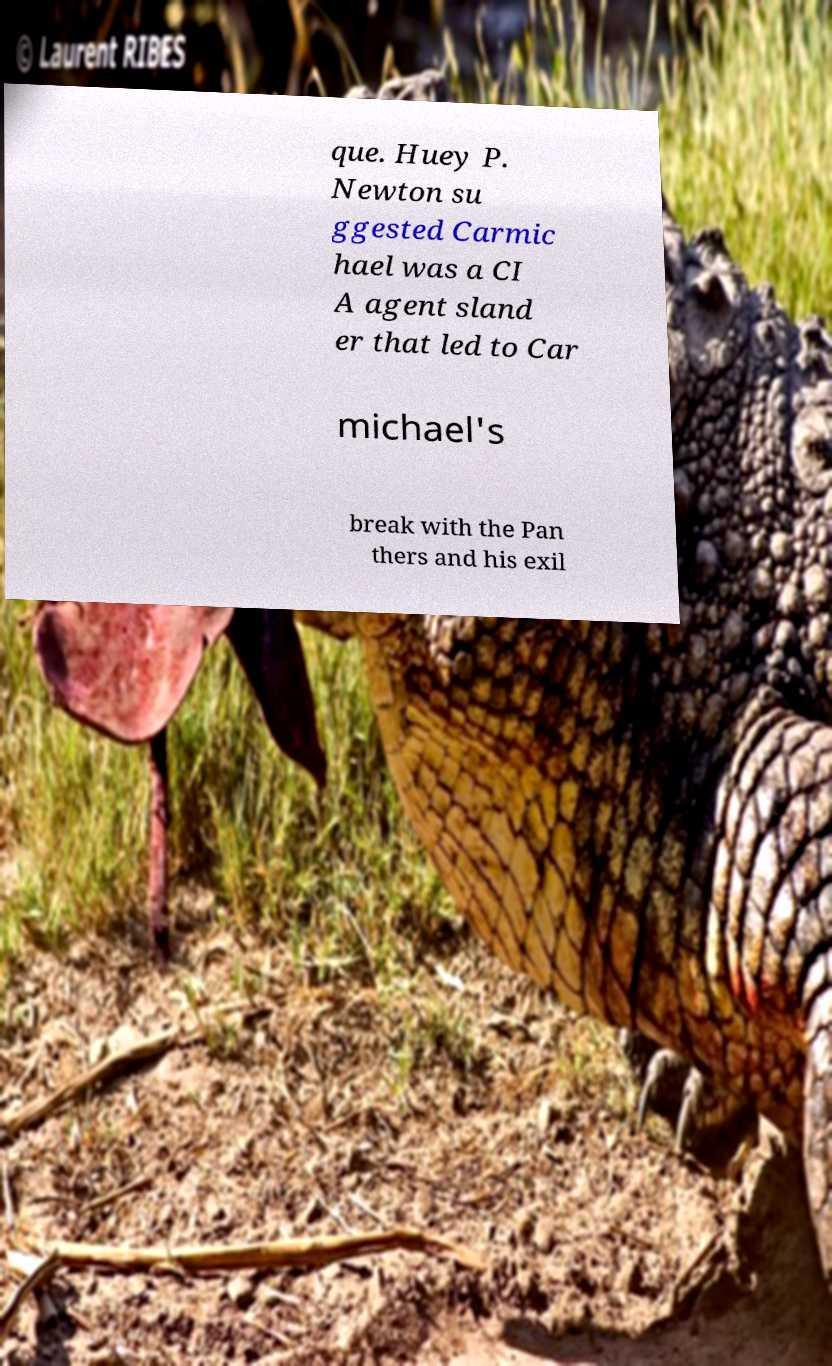Please identify and transcribe the text found in this image. que. Huey P. Newton su ggested Carmic hael was a CI A agent sland er that led to Car michael's break with the Pan thers and his exil 